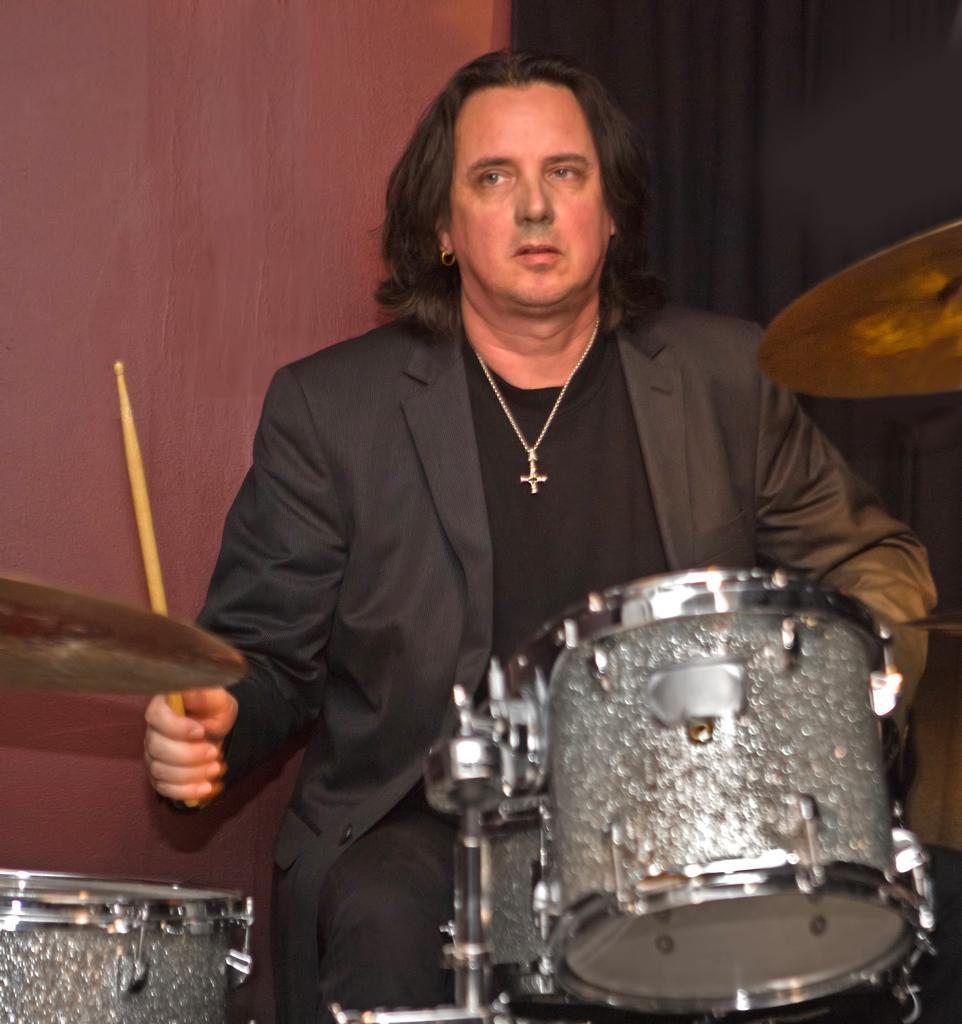In one or two sentences, can you explain what this image depicts? In the image there is a man sitting and there are drums in front of him, he is holding a stick in his hand. Behind the man there is a black curtain and a wall. 